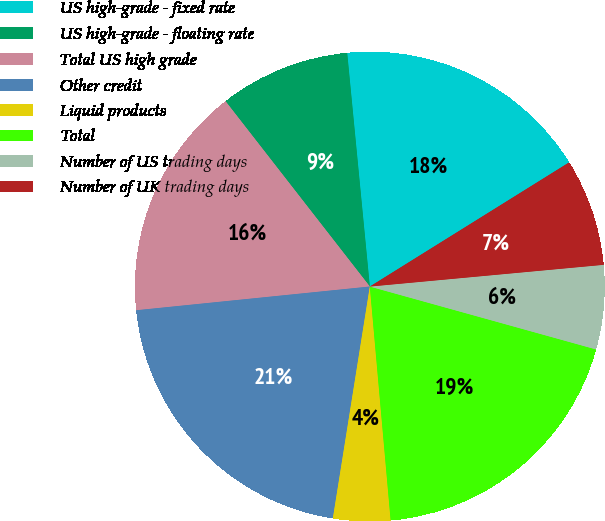Convert chart. <chart><loc_0><loc_0><loc_500><loc_500><pie_chart><fcel>US high-grade - fixed rate<fcel>US high-grade - floating rate<fcel>Total US high grade<fcel>Other credit<fcel>Liquid products<fcel>Total<fcel>Number of US trading days<fcel>Number of UK trading days<nl><fcel>17.67%<fcel>8.99%<fcel>16.08%<fcel>20.87%<fcel>3.93%<fcel>19.27%<fcel>5.79%<fcel>7.39%<nl></chart> 